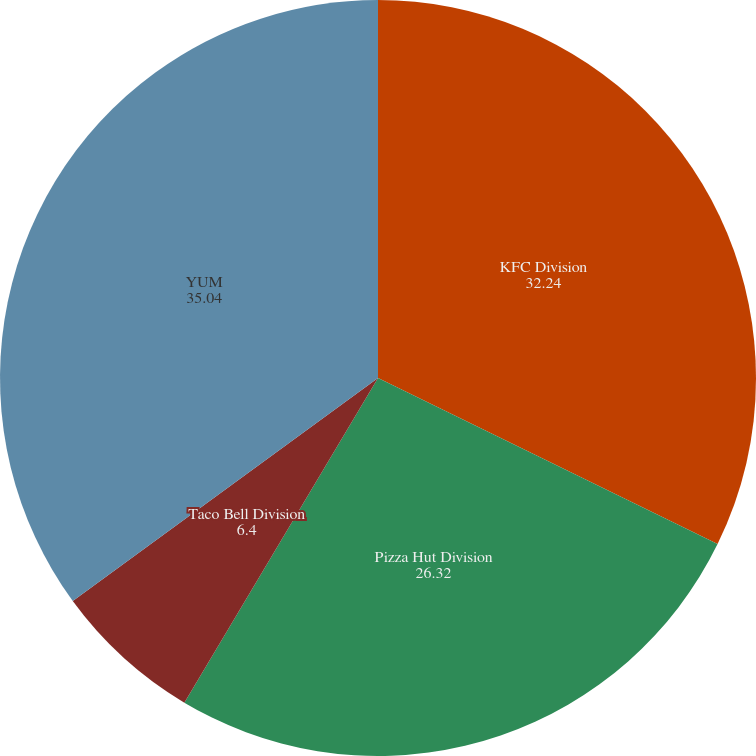<chart> <loc_0><loc_0><loc_500><loc_500><pie_chart><fcel>KFC Division<fcel>Pizza Hut Division<fcel>Taco Bell Division<fcel>YUM<nl><fcel>32.24%<fcel>26.32%<fcel>6.4%<fcel>35.04%<nl></chart> 